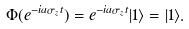Convert formula to latex. <formula><loc_0><loc_0><loc_500><loc_500>\Phi ( e ^ { - i a \sigma _ { z } t } ) = e ^ { - i a \sigma _ { z } t } | 1 \rangle = | 1 \rangle .</formula> 